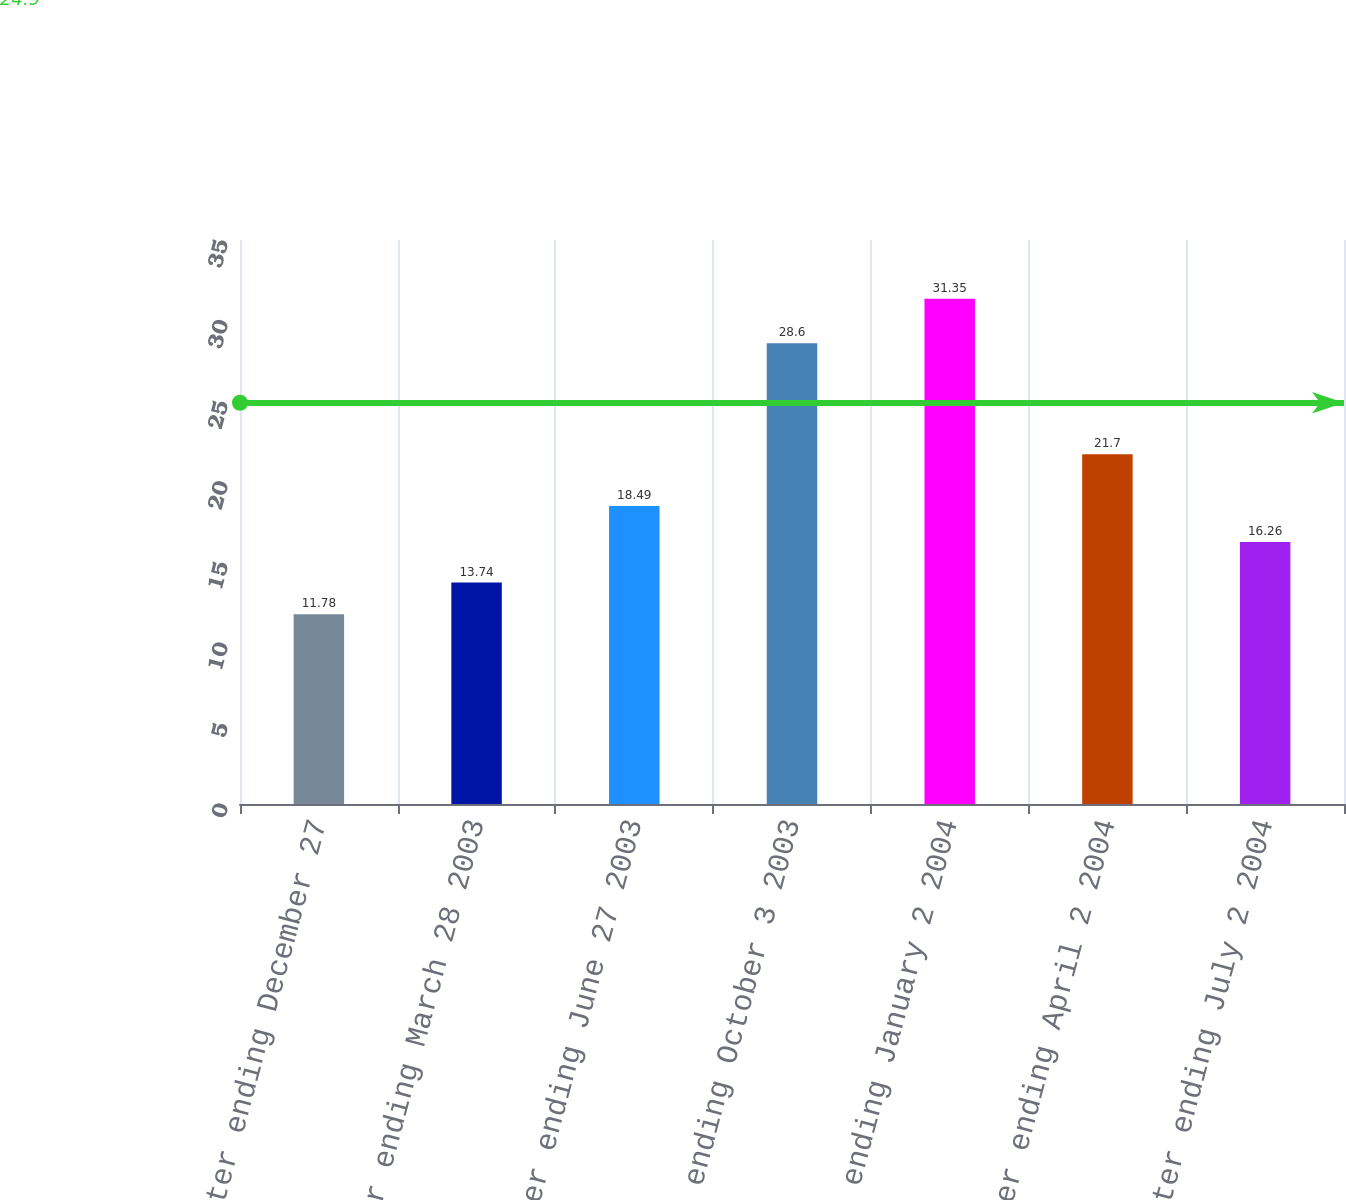Convert chart to OTSL. <chart><loc_0><loc_0><loc_500><loc_500><bar_chart><fcel>Quarter ending December 27<fcel>Quarter ending March 28 2003<fcel>Quarter ending June 27 2003<fcel>Quarter ending October 3 2003<fcel>Quarter ending January 2 2004<fcel>Quarter ending April 2 2004<fcel>Quarter ending July 2 2004<nl><fcel>11.78<fcel>13.74<fcel>18.49<fcel>28.6<fcel>31.35<fcel>21.7<fcel>16.26<nl></chart> 